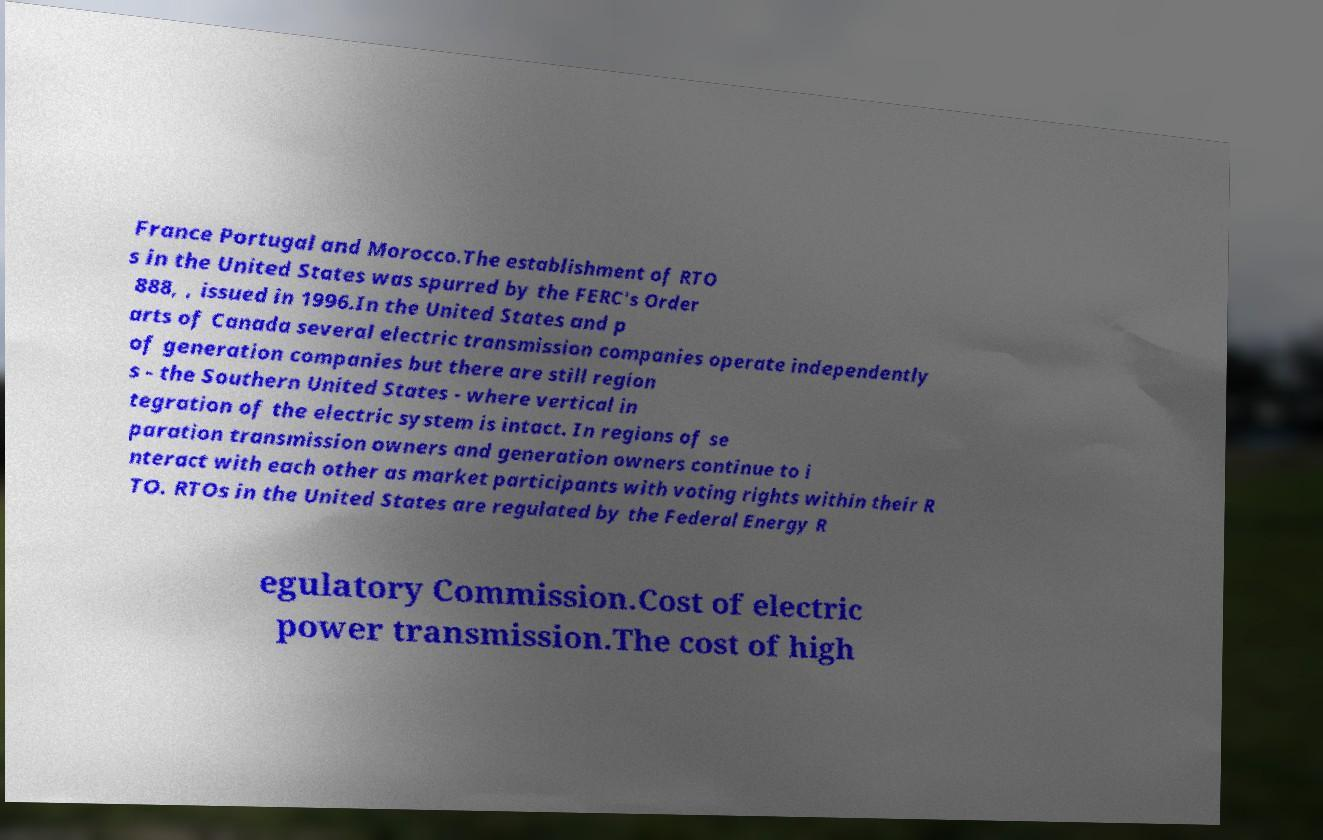What messages or text are displayed in this image? I need them in a readable, typed format. France Portugal and Morocco.The establishment of RTO s in the United States was spurred by the FERC's Order 888, , issued in 1996.In the United States and p arts of Canada several electric transmission companies operate independently of generation companies but there are still region s - the Southern United States - where vertical in tegration of the electric system is intact. In regions of se paration transmission owners and generation owners continue to i nteract with each other as market participants with voting rights within their R TO. RTOs in the United States are regulated by the Federal Energy R egulatory Commission.Cost of electric power transmission.The cost of high 